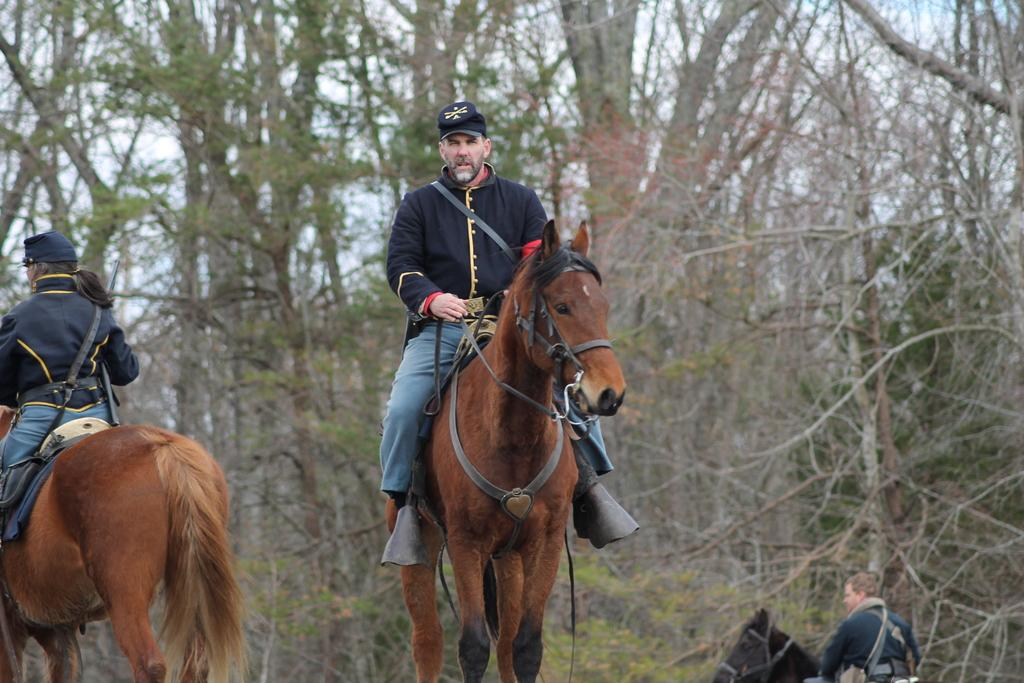What are the people in the image doing? The people in the image are riding horses. What type of natural environment can be seen in the image? There are trees visible in the image. What is visible in the background of the image? The sky is visible in the image. What is the chance of a fireman putting out a fire in the image? There is no fireman or fire present in the image, so it is not possible to determine the chance of a fire being put out. 